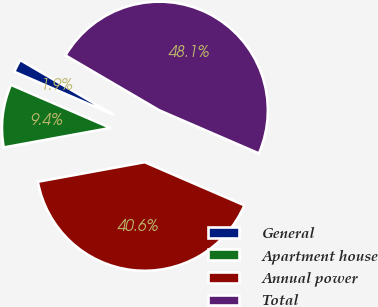Convert chart to OTSL. <chart><loc_0><loc_0><loc_500><loc_500><pie_chart><fcel>General<fcel>Apartment house<fcel>Annual power<fcel>Total<nl><fcel>1.93%<fcel>9.38%<fcel>40.62%<fcel>48.07%<nl></chart> 